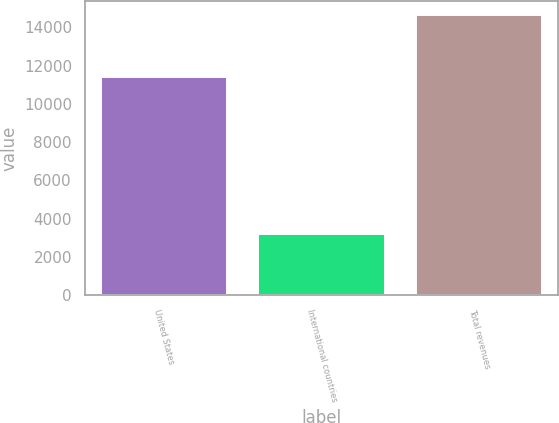Convert chart. <chart><loc_0><loc_0><loc_500><loc_500><bar_chart><fcel>United States<fcel>International countries<fcel>Total revenues<nl><fcel>11421<fcel>3221<fcel>14642<nl></chart> 